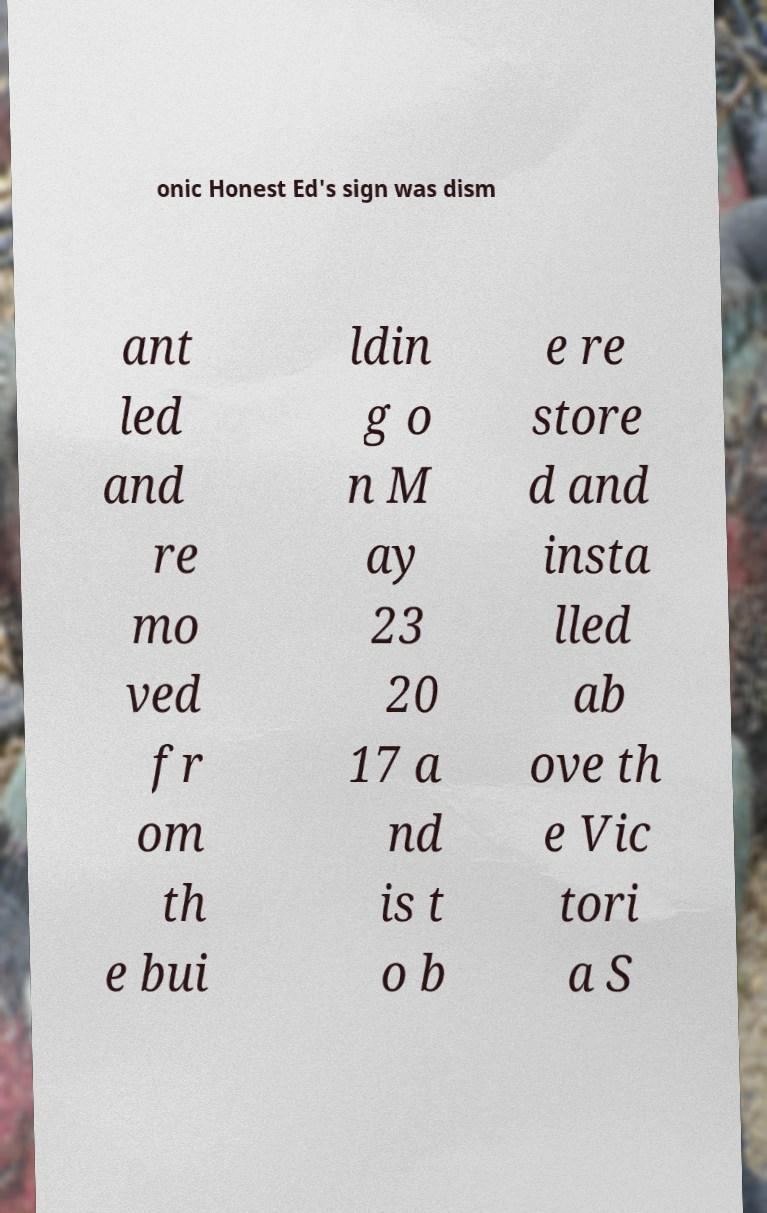Could you assist in decoding the text presented in this image and type it out clearly? onic Honest Ed's sign was dism ant led and re mo ved fr om th e bui ldin g o n M ay 23 20 17 a nd is t o b e re store d and insta lled ab ove th e Vic tori a S 